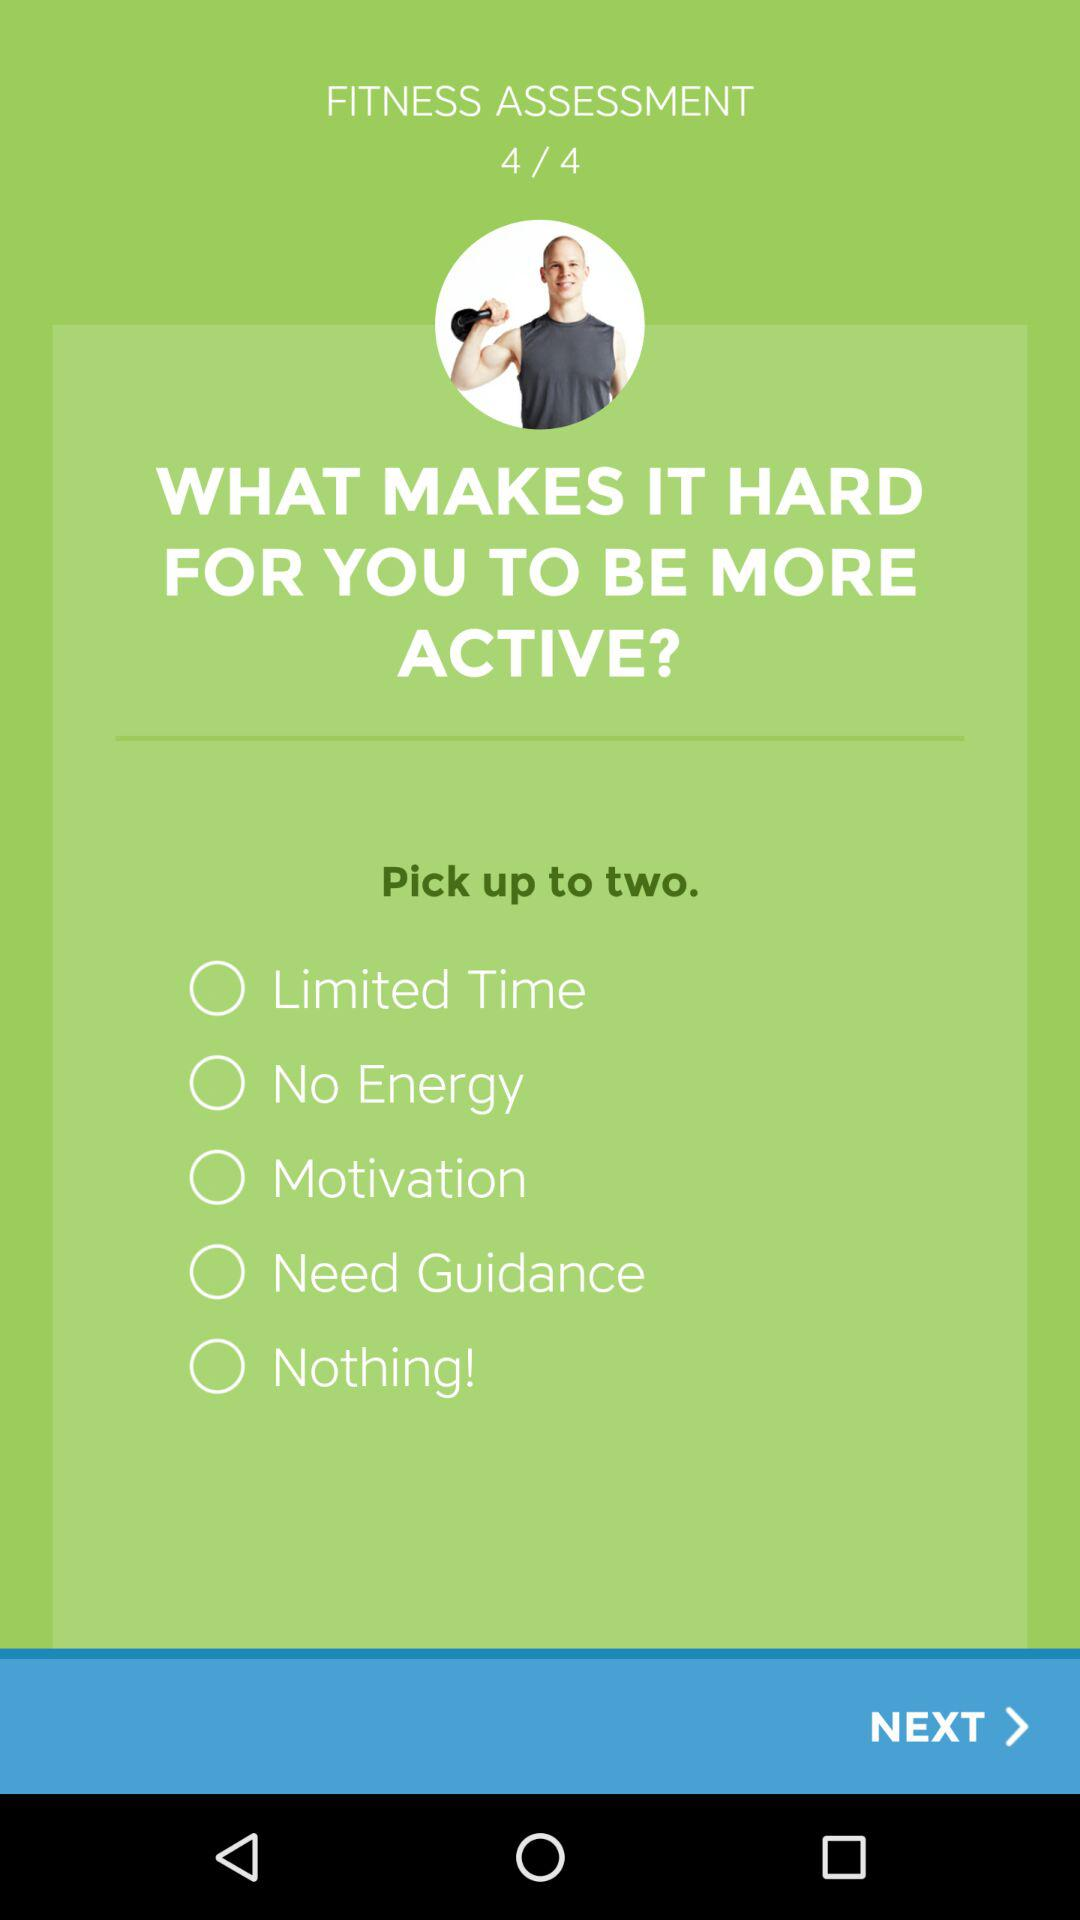How many fitness assessments are there? There are 4 fitness assessments. 